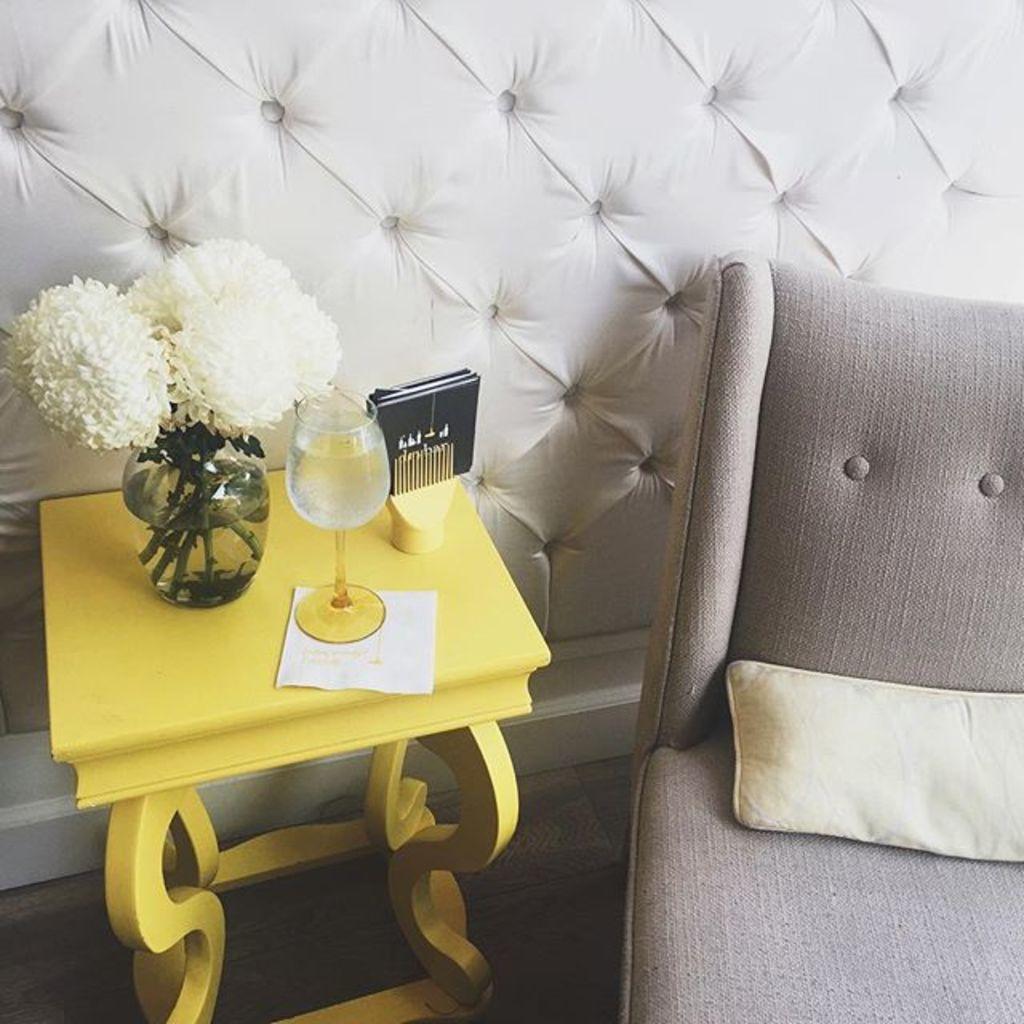Could you give a brief overview of what you see in this image? In this picture we can see table. On the table we can see glass,paper,flower,flower pot. This is floor. we can see chair. On the chair we can see pillow. 